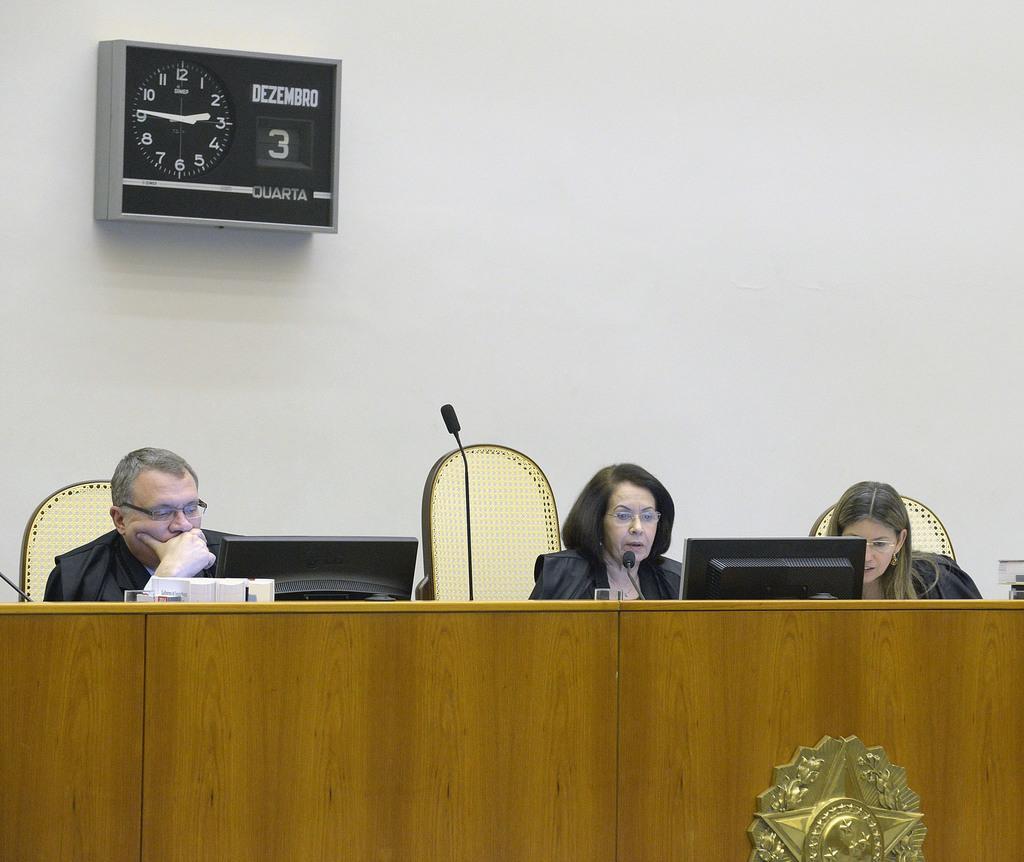How would you summarize this image in a sentence or two? In this image there are three persons sitting on the chairs, there are monitors, mike's, glasses and some other items on the table, and in the background there is a clock to the wall. 